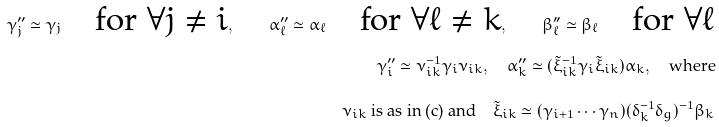Convert formula to latex. <formula><loc_0><loc_0><loc_500><loc_500>\gamma ^ { \prime \prime } _ { j } \simeq \gamma _ { j } \quad \text {for $\forall j\neq i$} , \quad \alpha ^ { \prime \prime } _ { \ell } \simeq \alpha _ { \ell } \quad \text {for $\forall \ell \neq k$} , \quad \beta ^ { \prime \prime } _ { \ell } \simeq \beta _ { \ell } \quad \text {for $\forall \ell $} \\ \gamma ^ { \prime \prime } _ { i } \simeq \nu _ { i k } ^ { - 1 } \gamma _ { i } \nu _ { i k } , \quad \alpha ^ { \prime \prime } _ { k } \simeq ( \tilde { \xi } _ { i k } ^ { - 1 } \gamma _ { i } \tilde { \xi } _ { i k } ) \alpha _ { k } , \quad \text {where} \\ \text {$\nu_{ik}$ is as in (c) and} \quad \tilde { \xi } _ { i k } \simeq ( \gamma _ { i + 1 } \cdots \gamma _ { n } ) ( \delta _ { k } ^ { - 1 } \delta _ { g } ) ^ { - 1 } \beta _ { k }</formula> 